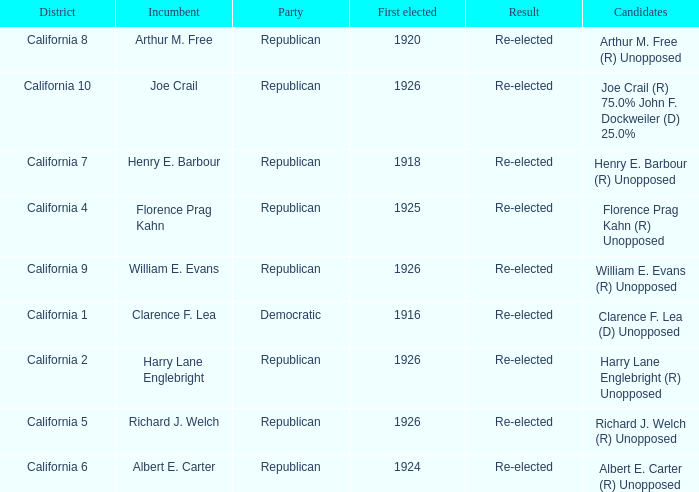What's the district with candidates being harry lane englebright (r) unopposed California 2. 